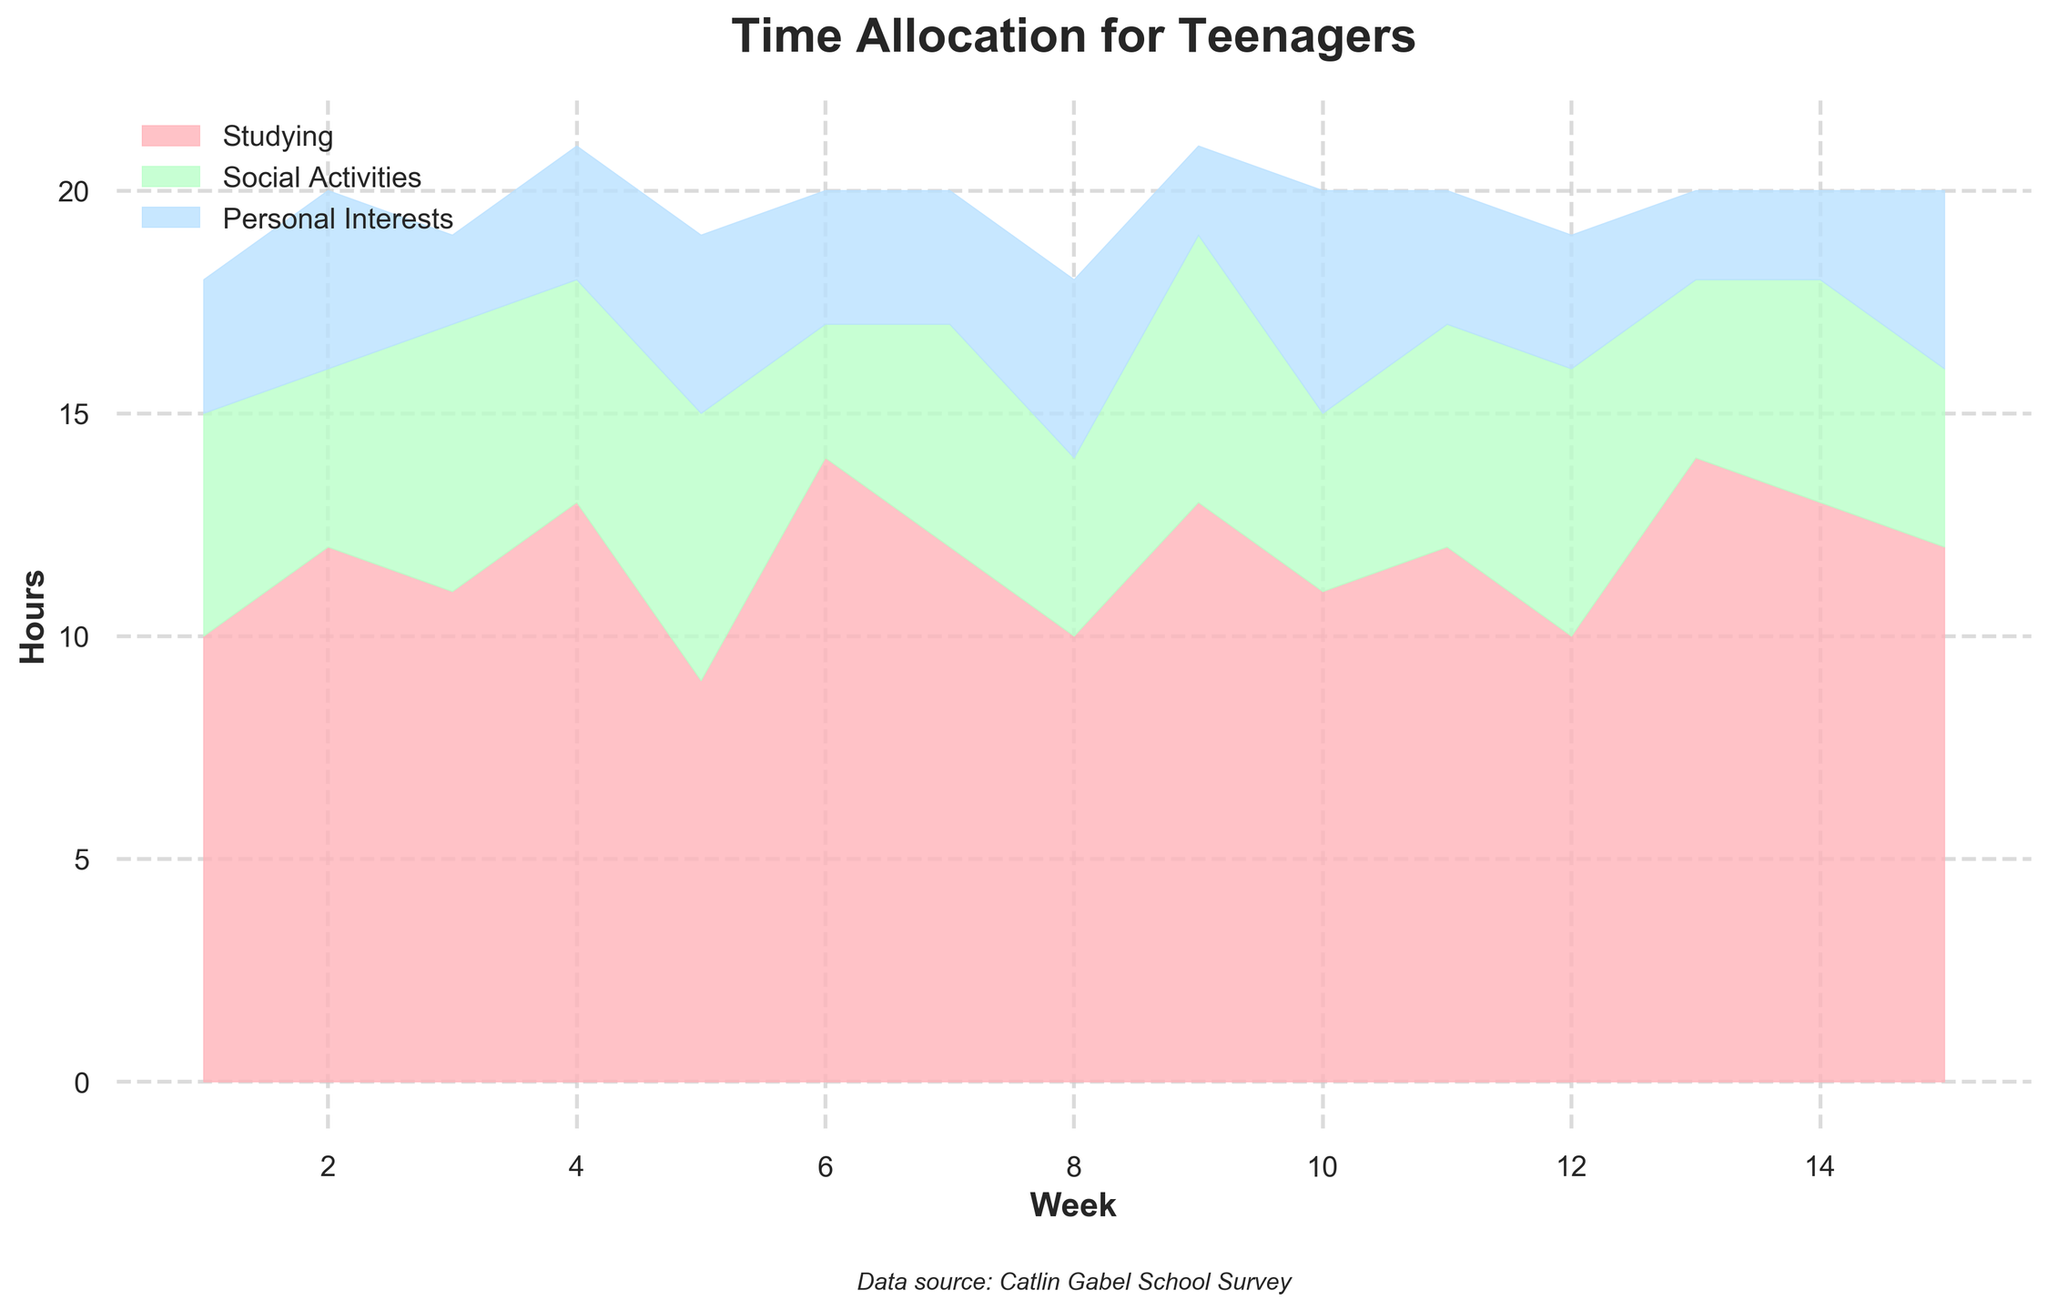What is the title of the graph? The title is displayed at the top of the graph with larger, bold font size, and it reads "Time Allocation for Teenagers".
Answer: Time Allocation for Teenagers What color represents the "Social Activities" category? The color for each category is designated in the legend found at the upper left of the graph. "Social Activities" is represented by a light green color.
Answer: Light green How many hours were allocated to "Studying" in Week 5? By looking at the first filled region (pink color) corresponding to Week 5 on the x-axis, we can see that "Studying" accounts for 9 hours.
Answer: 9 hours In which week did teenagers spend the most hours on "Personal Interests"? "Personal Interests" is represented by the blue region. By tracing the blue region that extends the furthest vertically above its underlying category, Week 10 shows the highest, with 5 hours.
Answer: Week 10 What is the total number of hours spent on all activities in Week 2? To find the total, add the hours for "Studying" (12), "Social Activities" (4), and "Personal Interests" (4) in Week 2. 12 + 4 + 4 = 20 hours.
Answer: 20 hours Which activity showed the most consistent number of hours each week? Consistency can be determined by observing which region's height changes the least throughout the graph. Both "Social Activities" and "Personal Interests" show variation, but "Studying" appears more consistent.
Answer: Studying What is the average number of hours spent on "Social Activities" over the 15 weeks? Sum the hours spent on "Social Activities" from Week 1 to Week 15 and divide by 15. (5+4+6+5+6+3+5+4+6+4+5+6+4+5+4) / 15 = 72 / 15 = 4.8 hours.
Answer: 4.8 hours Which week had the most total hours allocated, and what were the total hours? By comparing the vertical sum of all three regions for each week, Week 2 at 20 hours has the highest total. This includes 12 (Studying) + 4 (Social Activities) + 4 (Personal Interests).
Answer: Week 2, 20 hours In which week did the hours allocated to "Studying" see the biggest increase compared to the previous week? Compare the differences in hours per week for "Studying". The biggest increase is from Week 5 to Week 6, where "Studying" went from 9 to 14 hours, a 5-hour increase.
Answer: Week 6 